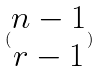<formula> <loc_0><loc_0><loc_500><loc_500>( \begin{matrix} n - 1 \\ r - 1 \end{matrix} )</formula> 